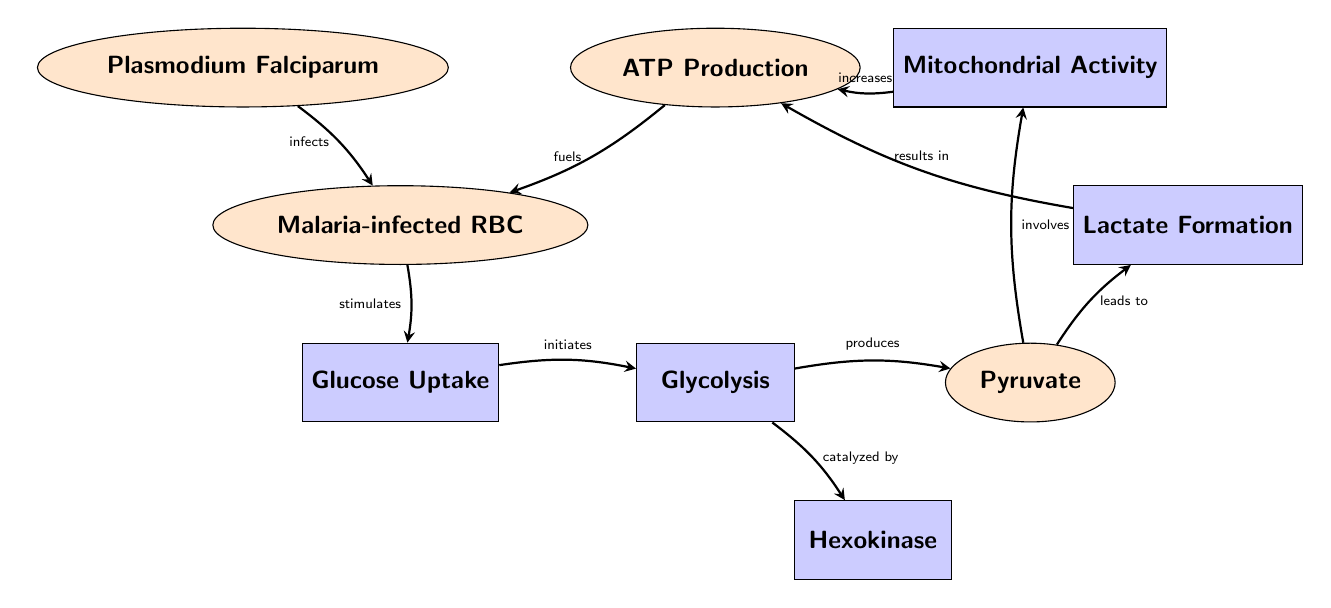What is the first process initiated in malaria-infected red blood cells? The diagram shows that the "Glucose Uptake" process is the first action initiated by the malaria-infected RBCs, as indicated by the directed edge from the Malaria-infected RBC node to the Glucose Uptake node.
Answer: Glucose Uptake What catalyzes the glycolysis process? The edge connecting the Glycolysis node to the Hexokinase node denotes that the glycolysis process is catalyzed by Hexokinase, which is the specific enzyme responsible for this reaction.
Answer: Hexokinase How many main processes are shown in the diagram? By counting the distinct nodes in the diagram, including processes and outcomes, we can see a total of six primary processes or components represented in the diagram, which are Glycolysis, Glucose Uptake, Pyruvate, Lactate Formation, Mitochondrial Activity, and ATP Production.
Answer: 6 What product is formed from glycolysis? The diagram illustrates that the product formed from glycolysis is Pyruvate, as indicated by the arrow leading from Glycolysis to Pyruvate.
Answer: Pyruvate What increases ATP production in malaria-infected red blood cells? The diagram indicates that Mitochondrial Activity is what "increases" ATP Production, as shown by the directed edge moving from Mitochondrial Activity to ATP Production.
Answer: Mitochondrial Activity What leads to lactate formation? The directed edge from Pyruvate to Lactate Formation specifies that Pyruvate is the component leading to the formation of Lactate in the metabolic pathway of malaria-infected RBCs.
Answer: Pyruvate Which organism infects red blood cells in the diagram? The diagram identifies "Plasmodium Falciparum" as the organism indicated by the edge labeled "infects" leading to the Malaria-infected RBC node, which signifies the source of infection.
Answer: Plasmodium Falciparum What fuels malaria-infected red blood cells? The arrow from ATP Production back to Malaria-infected RBC indicates that ATP Production "fuels" the malaria-infected cells, showing the dependency of these cells on ATP supply.
Answer: ATP Production 